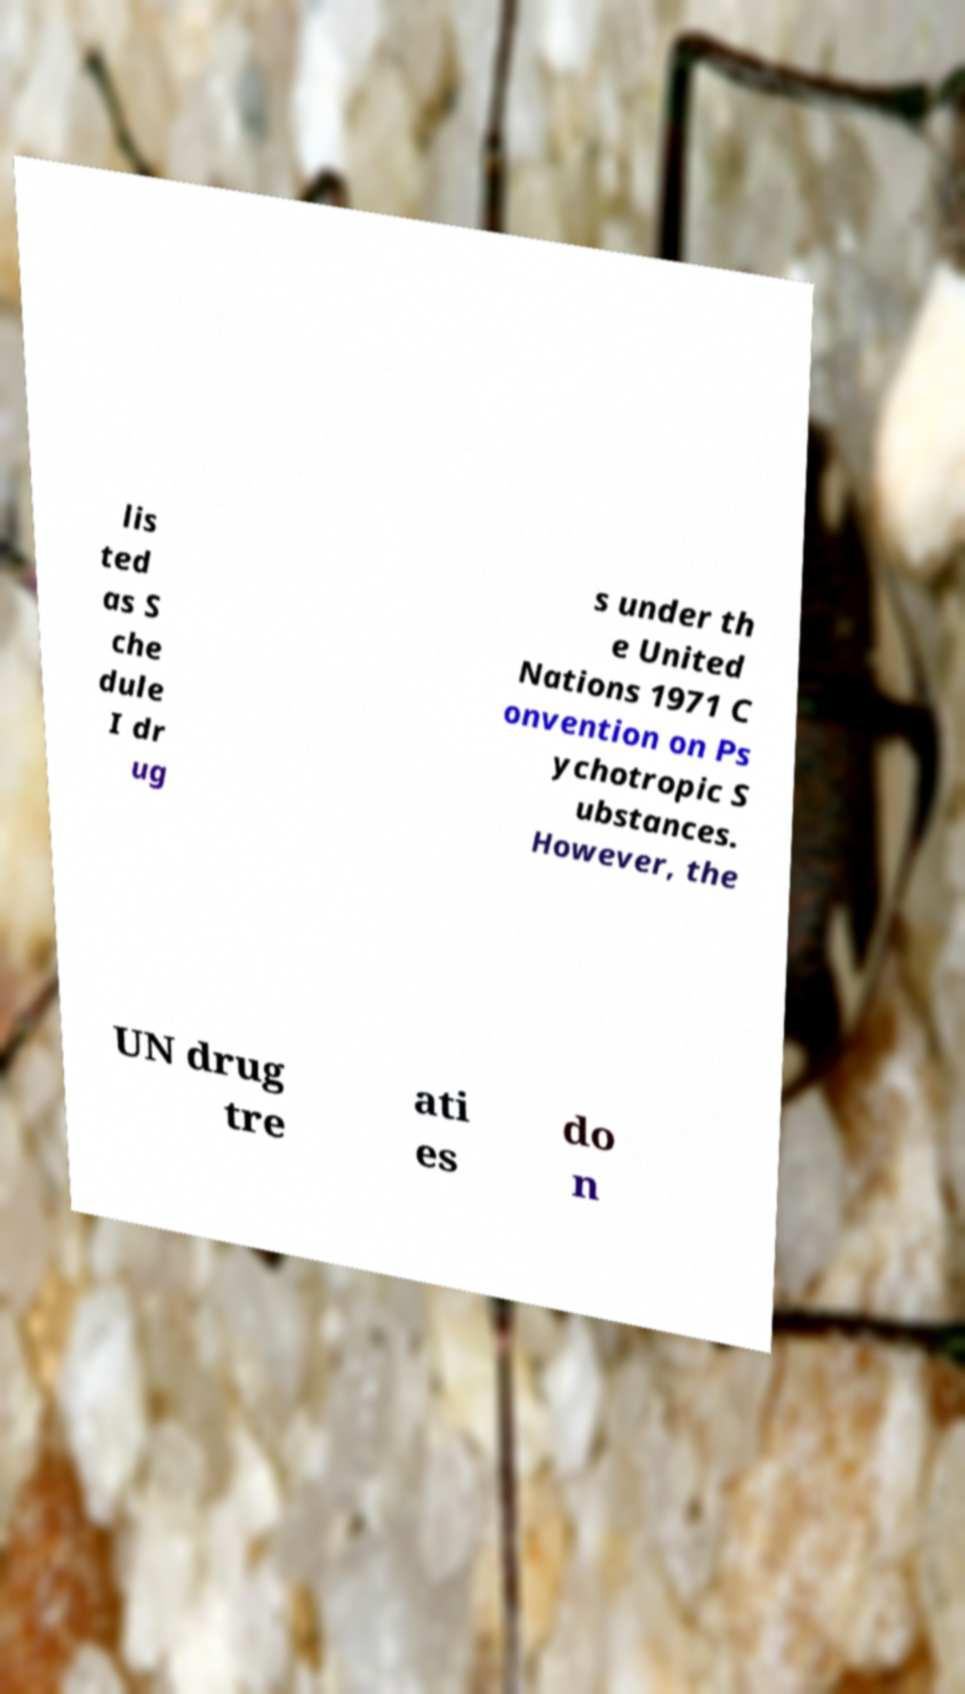Could you extract and type out the text from this image? lis ted as S che dule I dr ug s under th e United Nations 1971 C onvention on Ps ychotropic S ubstances. However, the UN drug tre ati es do n 